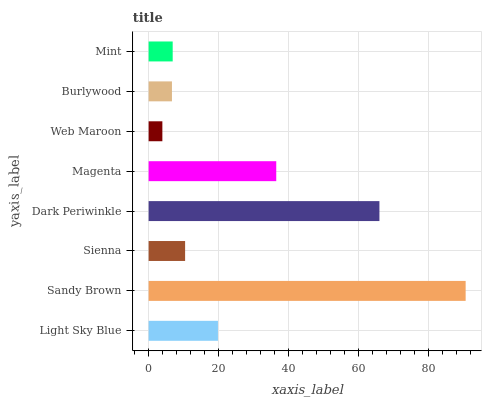Is Web Maroon the minimum?
Answer yes or no. Yes. Is Sandy Brown the maximum?
Answer yes or no. Yes. Is Sienna the minimum?
Answer yes or no. No. Is Sienna the maximum?
Answer yes or no. No. Is Sandy Brown greater than Sienna?
Answer yes or no. Yes. Is Sienna less than Sandy Brown?
Answer yes or no. Yes. Is Sienna greater than Sandy Brown?
Answer yes or no. No. Is Sandy Brown less than Sienna?
Answer yes or no. No. Is Light Sky Blue the high median?
Answer yes or no. Yes. Is Sienna the low median?
Answer yes or no. Yes. Is Sienna the high median?
Answer yes or no. No. Is Sandy Brown the low median?
Answer yes or no. No. 